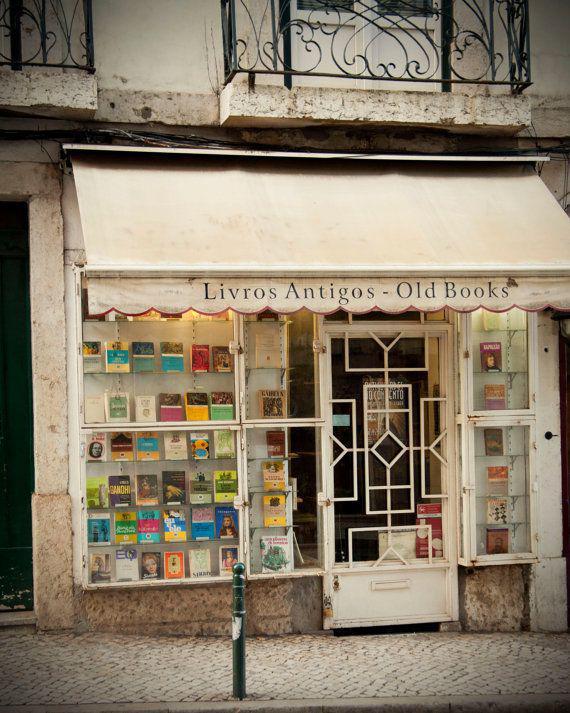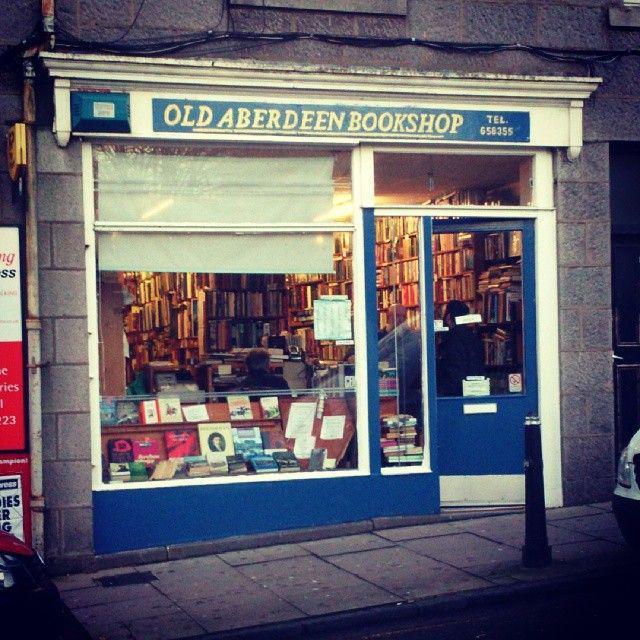The first image is the image on the left, the second image is the image on the right. For the images shown, is this caption "In the image to the right, the outside of the old bookshop has some blue paint." true? Answer yes or no. Yes. 